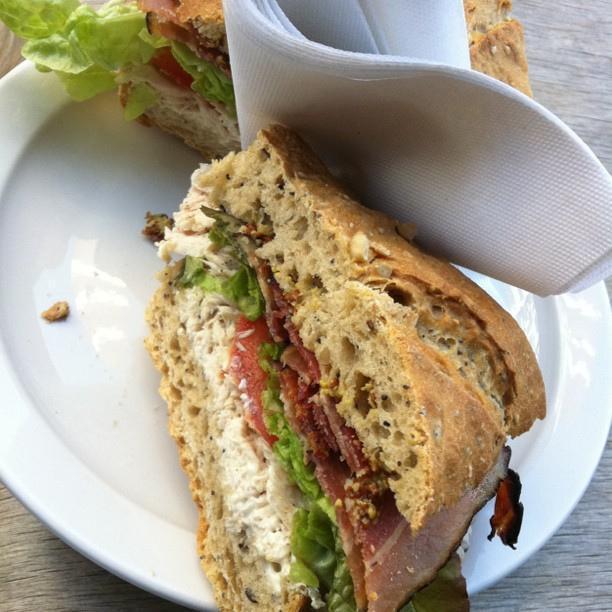How many dining tables are there?
Give a very brief answer. 1. How many sandwiches are there?
Give a very brief answer. 2. How many train tracks?
Give a very brief answer. 0. 